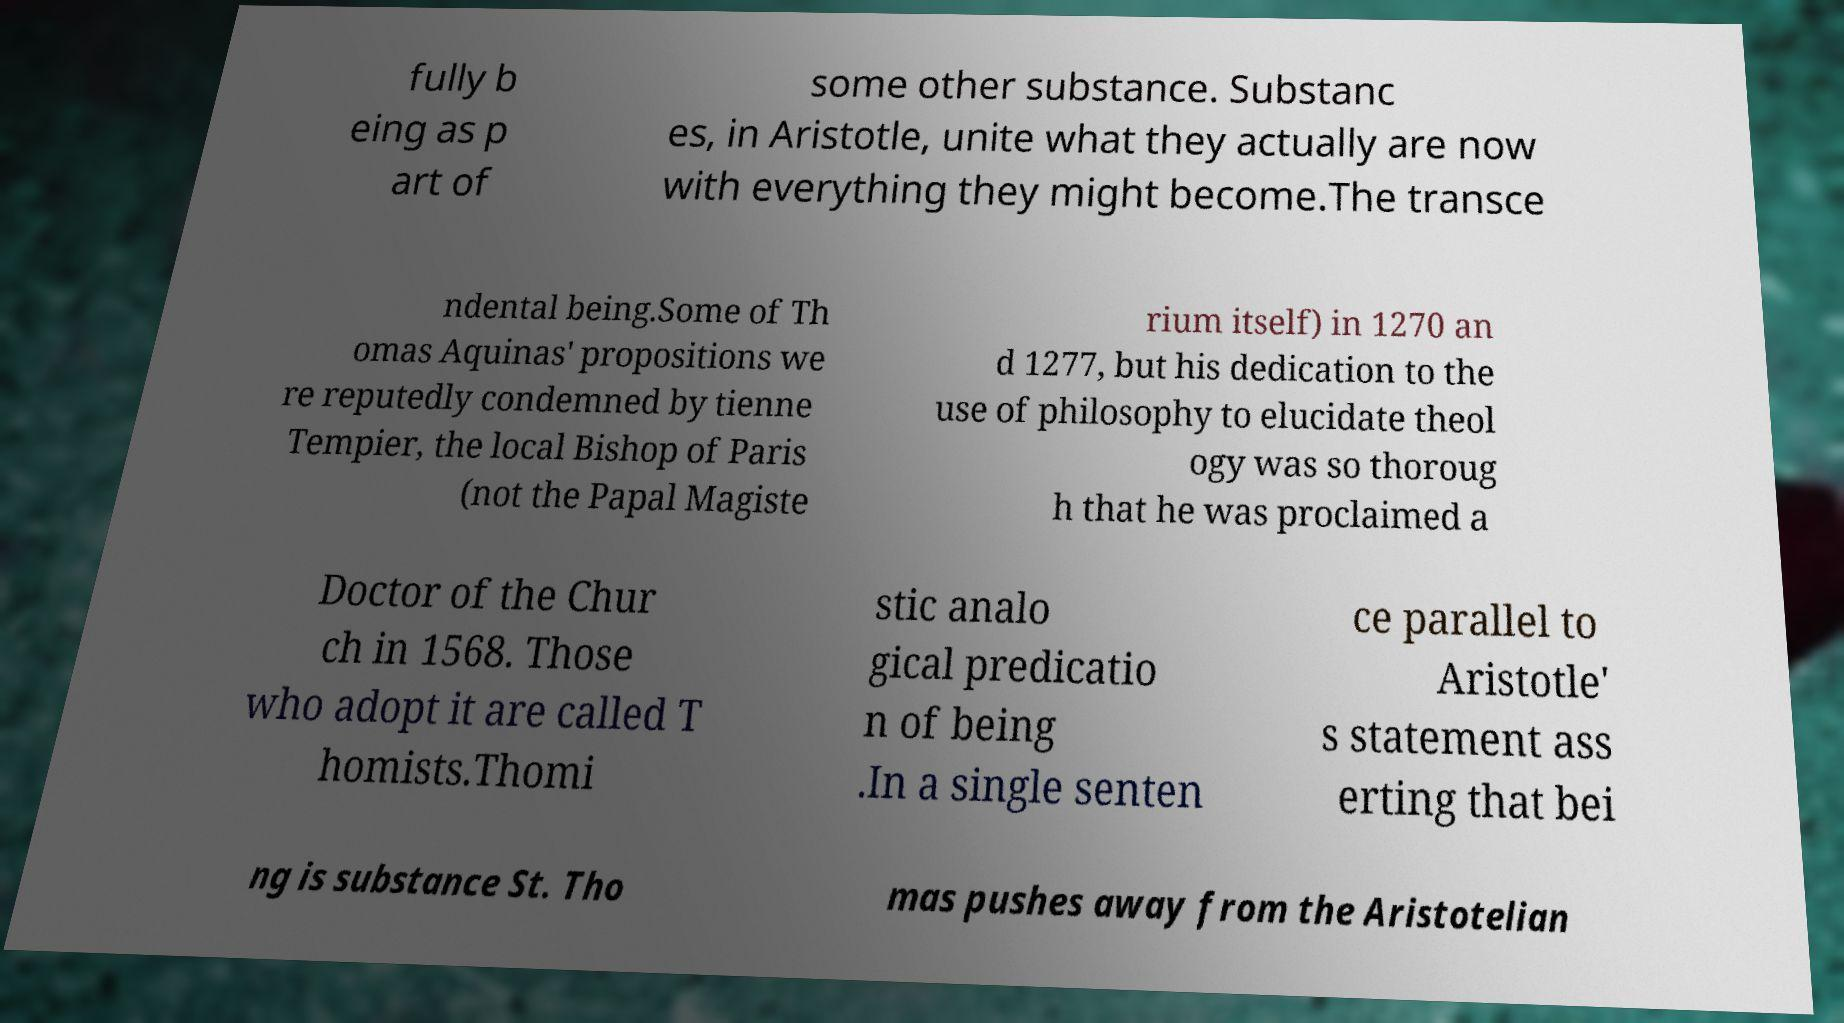There's text embedded in this image that I need extracted. Can you transcribe it verbatim? fully b eing as p art of some other substance. Substanc es, in Aristotle, unite what they actually are now with everything they might become.The transce ndental being.Some of Th omas Aquinas' propositions we re reputedly condemned by tienne Tempier, the local Bishop of Paris (not the Papal Magiste rium itself) in 1270 an d 1277, but his dedication to the use of philosophy to elucidate theol ogy was so thoroug h that he was proclaimed a Doctor of the Chur ch in 1568. Those who adopt it are called T homists.Thomi stic analo gical predicatio n of being .In a single senten ce parallel to Aristotle' s statement ass erting that bei ng is substance St. Tho mas pushes away from the Aristotelian 